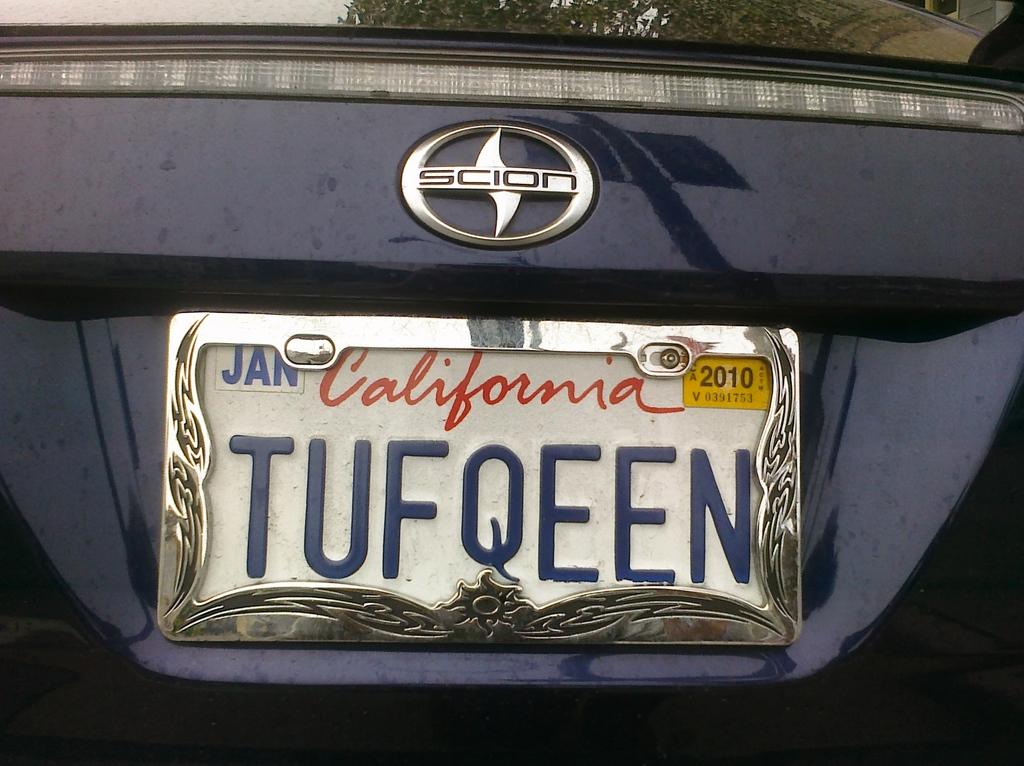Which state is this license plate?
Your response must be concise. California. What month is the plate good until?
Ensure brevity in your answer.  January. 